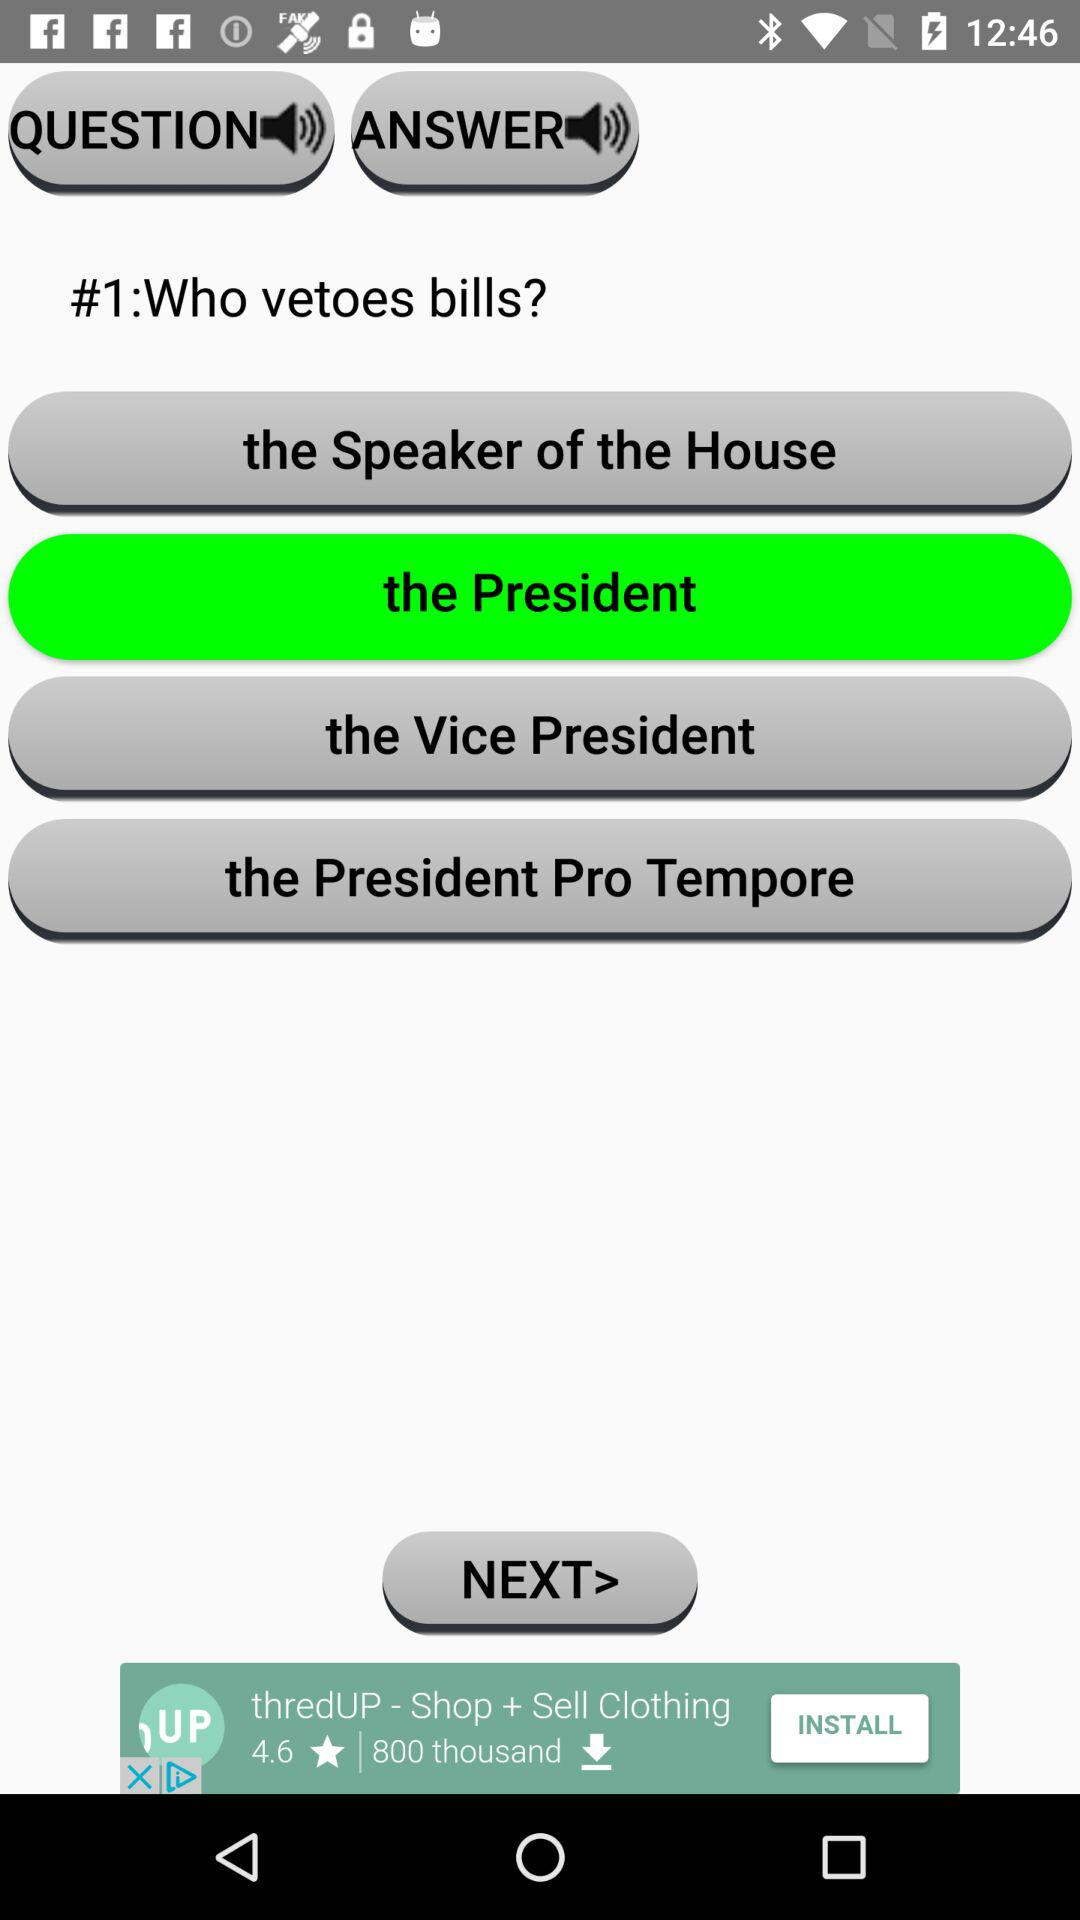How many options are there for who vetoes bills?
Answer the question using a single word or phrase. 4 